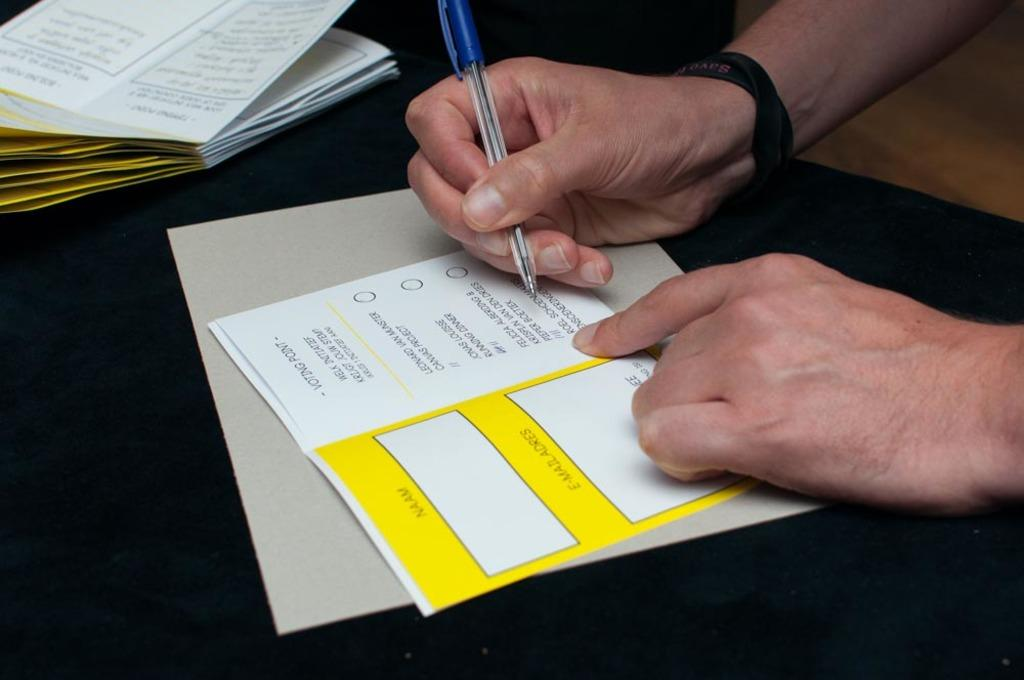<image>
Summarize the visual content of the image. A man fills out a voting point form. 